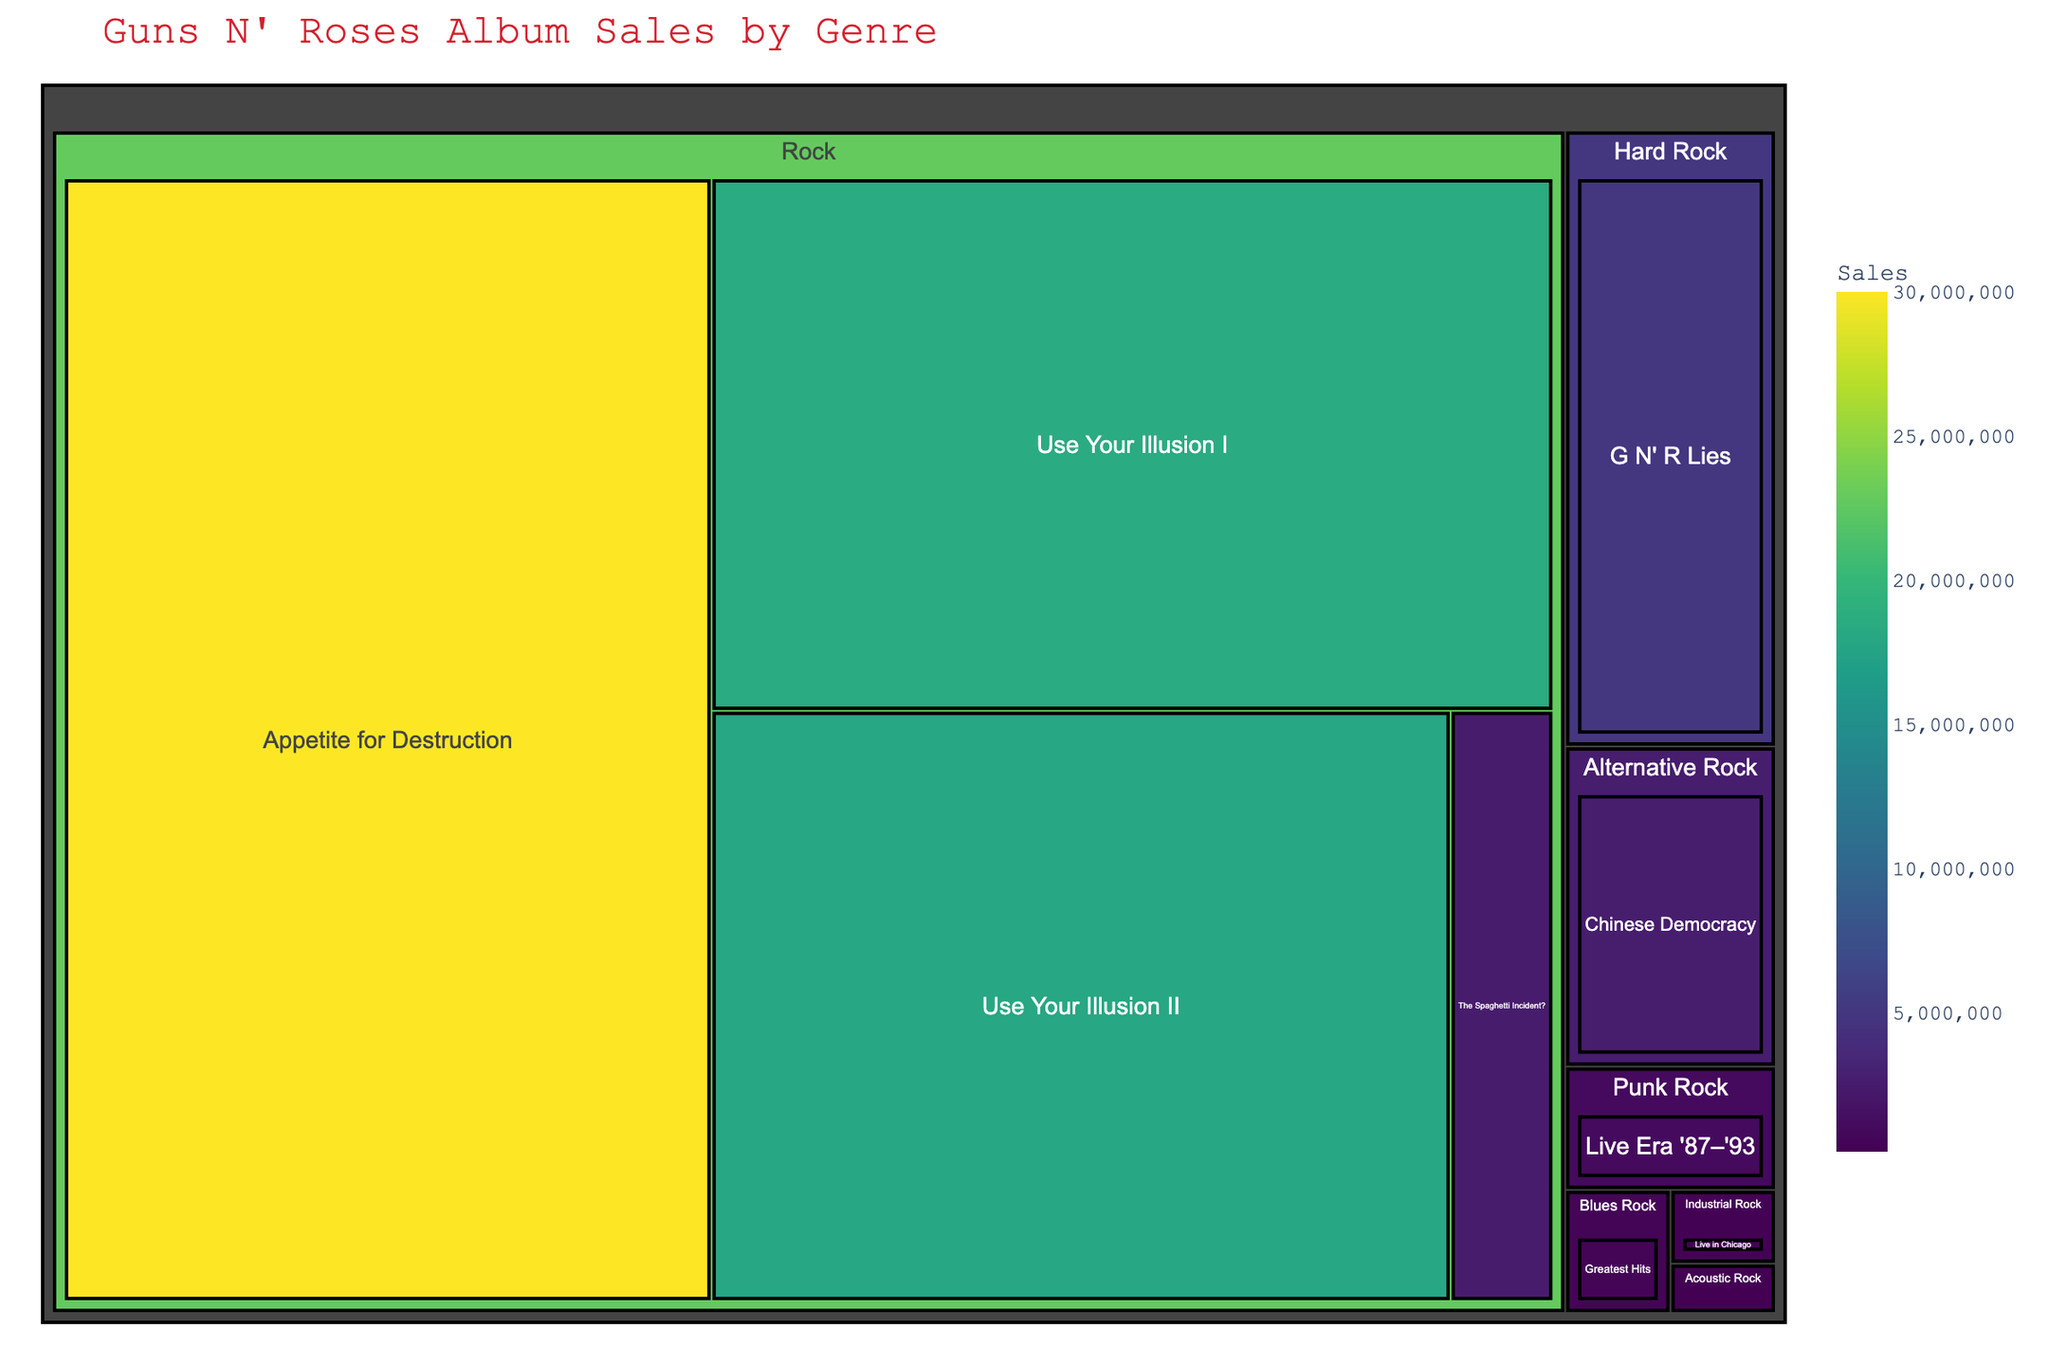What is the title of the treemap? The title is usually placed at the top of the figure and describes what the treemap is about. In this case, it tells us the focus of the data visualization.
Answer: Guns N' Roses Album Sales by Genre How many albums fall under the 'Rock' genre? Each box in the treemap represents an album, and the first level breakdown shows the genres. Count the albums under the 'Rock' section.
Answer: 4 Which album has the highest sales? The size of the blocks in a treemap represents the sales. The largest block would have the highest sales.
Answer: Appetite for Destruction What are the total sales of albums under the 'Rock' genre? Add the sales figures for all albums listed under the 'Rock' genre: Appetite for Destruction, Use Your Illusion I, Use Your Illusion II, and The Spaghetti Incident?.
Answer: 68,500,000 Which genre has the smallest representation in terms of sales? The size of each genre section reflects the total sales of albums within it. The smallest section in terms of area will represent the genre with the smallest sales.
Answer: Acoustic Rock How does the sales of "Chinese Democracy" compare to "G N' R Lies"? The areas of the corresponding blocks indicate the album sales, allowing for a visual comparison.
Answer: Chinese Democracy: 2,600,000, G N' R Lies: 5,000,000 What is the average sales amount of all albums? Add all the album sales figures and divide by the number of albums. (30,000,000 + 18,500,000 + 18,000,000 + 5,000,000 + 2,600,000 + 2,500,000 + 1,000,000 + 500,000 + 300,000 + 200,000) / 10
Answer: 7,160,000 Are there any genres represented by more than one album? By examining the blocks under each genre category, determine if any genres have multiple sub-blocks (albums).
Answer: Yes, Rock Which album has the least sales, and how can you visually identify it? Look for the smallest block within the entire treemap, as it represents the album with the least sales. The name of the album will be inside this block.
Answer: Acoustic Sessions, 200,000 